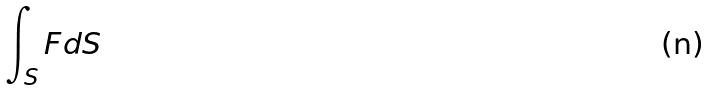Convert formula to latex. <formula><loc_0><loc_0><loc_500><loc_500>\int _ { S } F d S</formula> 